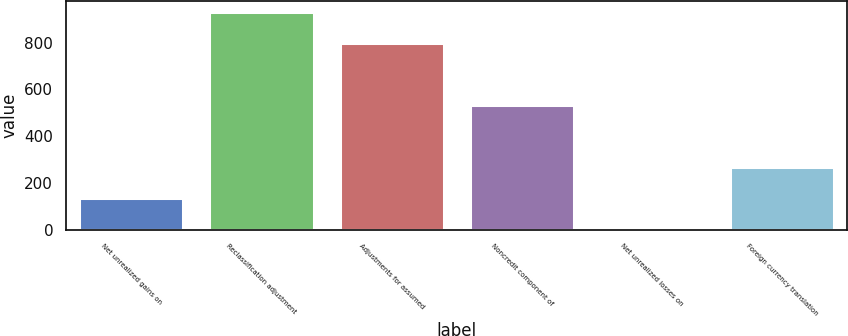<chart> <loc_0><loc_0><loc_500><loc_500><bar_chart><fcel>Net unrealized gains on<fcel>Reclassification adjustment<fcel>Adjustments for assumed<fcel>Noncredit component of<fcel>Net unrealized losses on<fcel>Foreign currency translation<nl><fcel>134.61<fcel>933.27<fcel>800.16<fcel>533.94<fcel>1.5<fcel>267.72<nl></chart> 